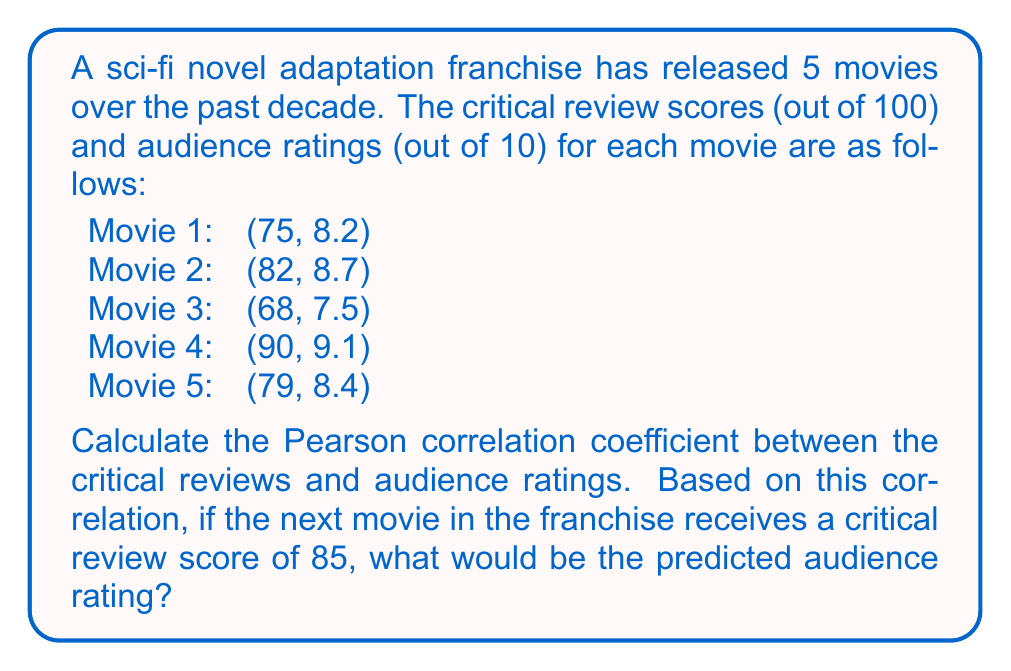Provide a solution to this math problem. To solve this problem, we'll follow these steps:

1. Calculate the Pearson correlation coefficient (r) between critical reviews (x) and audience ratings (y).
2. Use the correlation to predict the audience rating for a critical review score of 85.

Step 1: Calculating the Pearson correlation coefficient

The formula for the Pearson correlation coefficient is:

$$ r = \frac{\sum_{i=1}^{n} (x_i - \bar{x})(y_i - \bar{y})}{\sqrt{\sum_{i=1}^{n} (x_i - \bar{x})^2 \sum_{i=1}^{n} (y_i - \bar{y})^2}} $$

First, we need to calculate the means:

$\bar{x} = \frac{75 + 82 + 68 + 90 + 79}{5} = 78.8$
$\bar{y} = \frac{8.2 + 8.7 + 7.5 + 9.1 + 8.4}{5} = 8.38$

Now, we can calculate the numerator and denominator:

Numerator: $\sum_{i=1}^{n} (x_i - \bar{x})(y_i - \bar{y}) = 51.66$
Denominator: $\sqrt{\sum_{i=1}^{n} (x_i - \bar{x})^2 \sum_{i=1}^{n} (y_i - \bar{y})^2} = \sqrt{326.8 \times 1.3276} = 20.81$

Therefore, the Pearson correlation coefficient is:

$$ r = \frac{51.66}{20.81} = 0.9928 $$

Step 2: Predicting the audience rating

To predict the audience rating for a critical review score of 85, we can use the regression line equation:

$$ y = m(x - \bar{x}) + \bar{y} $$

where $m = r \frac{s_y}{s_x}$, and $s_x$ and $s_y$ are the standard deviations of x and y respectively.

$s_x = \sqrt{\frac{\sum_{i=1}^{n} (x_i - \bar{x})^2}{n-1}} = \sqrt{\frac{326.8}{4}} = 9.05$
$s_y = \sqrt{\frac{\sum_{i=1}^{n} (y_i - \bar{y})^2}{n-1}} = \sqrt{\frac{1.3276}{4}} = 0.576$

$m = 0.9928 \times \frac{0.576}{9.05} = 0.0632$

Now we can predict the audience rating for x = 85:

$y = 0.0632(85 - 78.8) + 8.38 = 8.77$
Answer: 8.77 